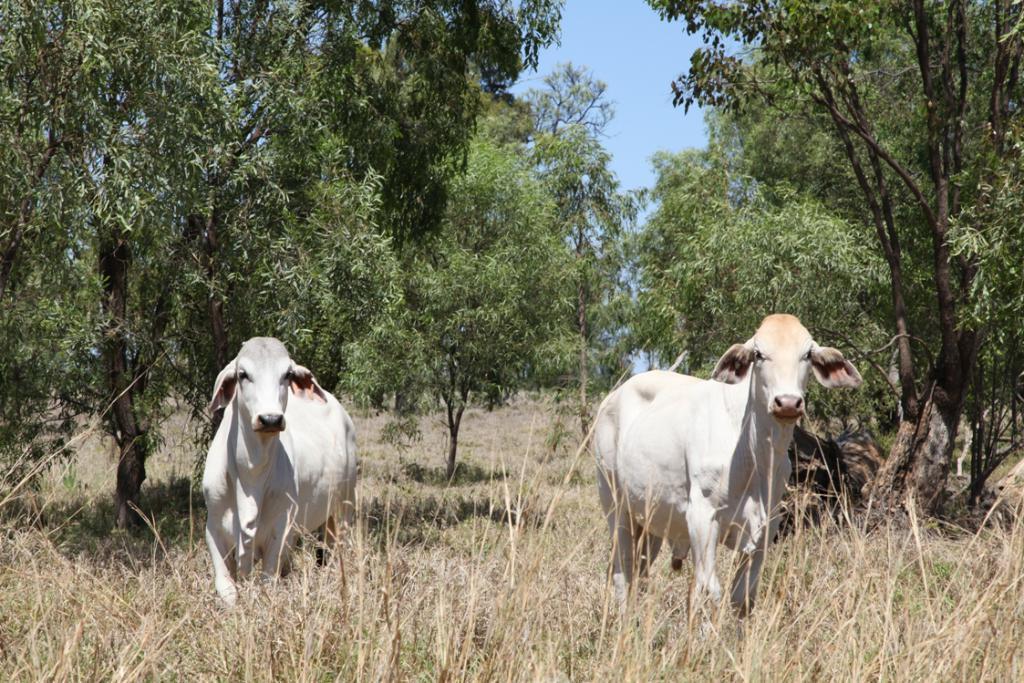How would you summarize this image in a sentence or two? In this image I can see grass ground and on it I can see two white colour cows are standing. In the background I can see number of trees and the sky. 